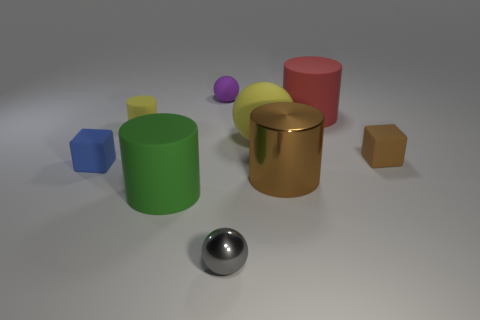Add 1 big brown things. How many objects exist? 10 Subtract all cylinders. How many objects are left? 5 Add 3 tiny yellow things. How many tiny yellow things are left? 4 Add 4 metallic spheres. How many metallic spheres exist? 5 Subtract 0 blue spheres. How many objects are left? 9 Subtract all large balls. Subtract all large spheres. How many objects are left? 7 